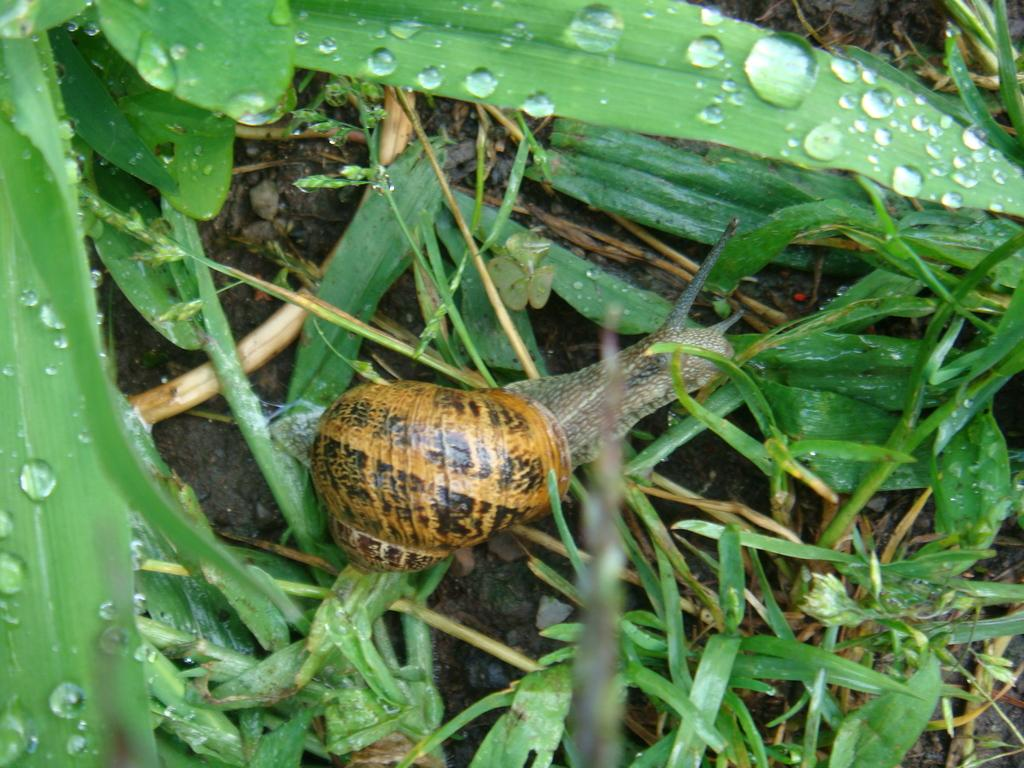What type of animal is in the image? There is a snail in the image. What is the snail's location in the image? The snail is on the grass. What type of roll can be seen in the image? There is no roll present in the image; it features a snail on the grass. What type of school is depicted in the image? There is no school present in the image; it features a snail on the grass. 